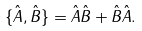Convert formula to latex. <formula><loc_0><loc_0><loc_500><loc_500>\{ { \hat { A } } , { \hat { B } } \} = { \hat { A } } { \hat { B } } + { \hat { B } } { \hat { A } } .</formula> 